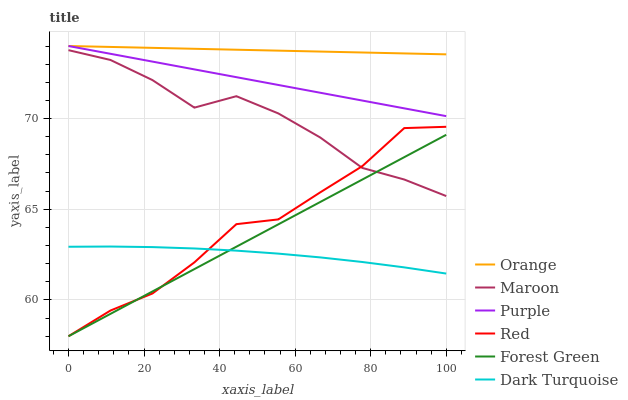Does Dark Turquoise have the minimum area under the curve?
Answer yes or no. Yes. Does Orange have the maximum area under the curve?
Answer yes or no. Yes. Does Maroon have the minimum area under the curve?
Answer yes or no. No. Does Maroon have the maximum area under the curve?
Answer yes or no. No. Is Forest Green the smoothest?
Answer yes or no. Yes. Is Red the roughest?
Answer yes or no. Yes. Is Dark Turquoise the smoothest?
Answer yes or no. No. Is Dark Turquoise the roughest?
Answer yes or no. No. Does Forest Green have the lowest value?
Answer yes or no. Yes. Does Dark Turquoise have the lowest value?
Answer yes or no. No. Does Orange have the highest value?
Answer yes or no. Yes. Does Maroon have the highest value?
Answer yes or no. No. Is Dark Turquoise less than Maroon?
Answer yes or no. Yes. Is Orange greater than Maroon?
Answer yes or no. Yes. Does Purple intersect Orange?
Answer yes or no. Yes. Is Purple less than Orange?
Answer yes or no. No. Is Purple greater than Orange?
Answer yes or no. No. Does Dark Turquoise intersect Maroon?
Answer yes or no. No. 